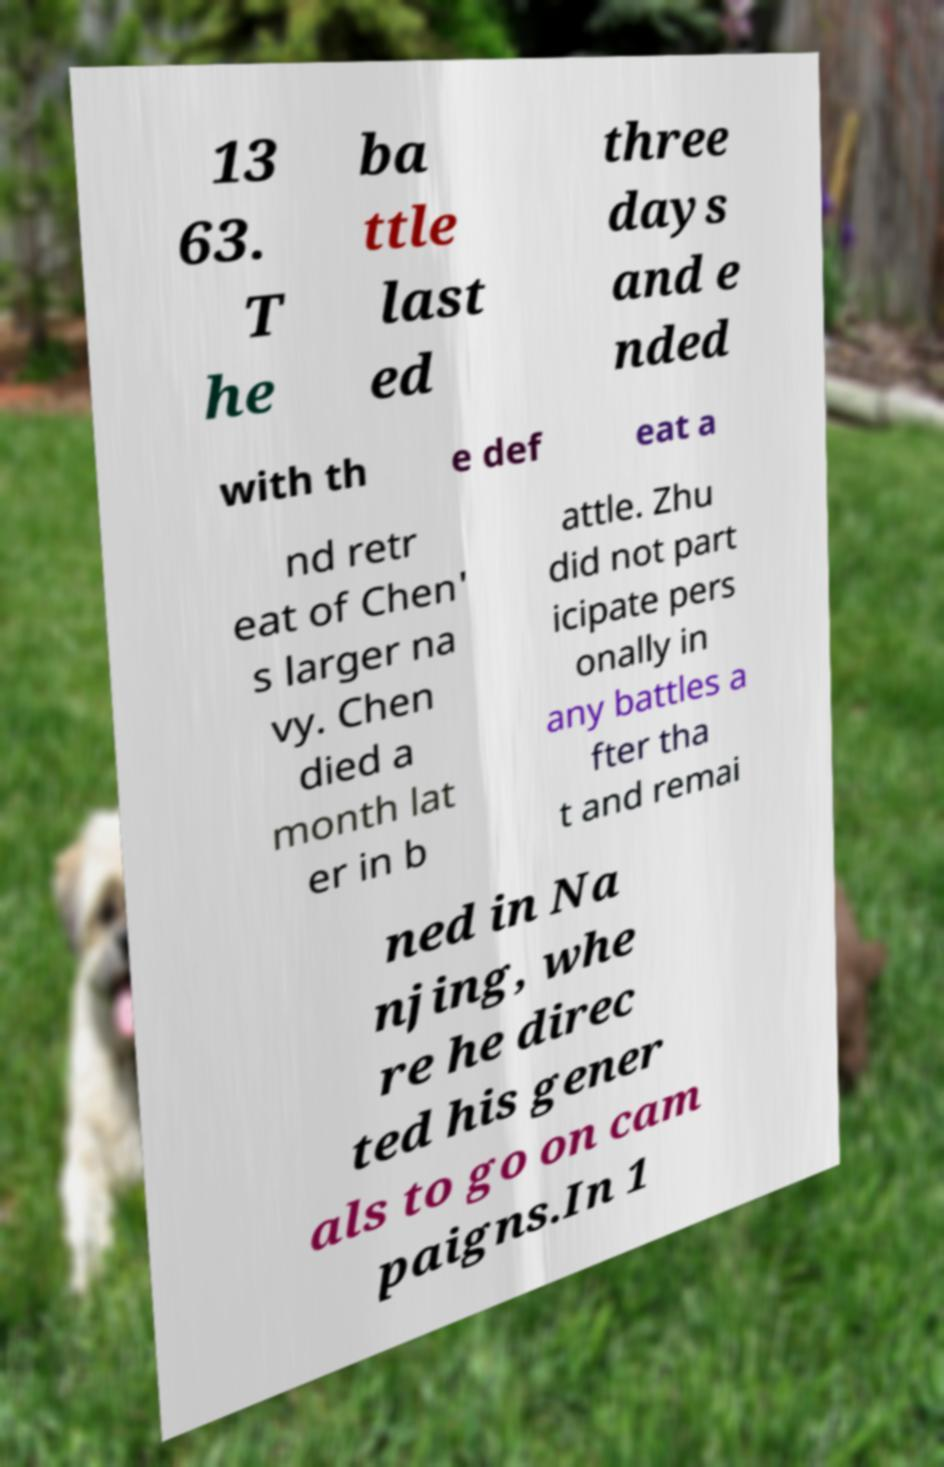Can you read and provide the text displayed in the image?This photo seems to have some interesting text. Can you extract and type it out for me? 13 63. T he ba ttle last ed three days and e nded with th e def eat a nd retr eat of Chen' s larger na vy. Chen died a month lat er in b attle. Zhu did not part icipate pers onally in any battles a fter tha t and remai ned in Na njing, whe re he direc ted his gener als to go on cam paigns.In 1 